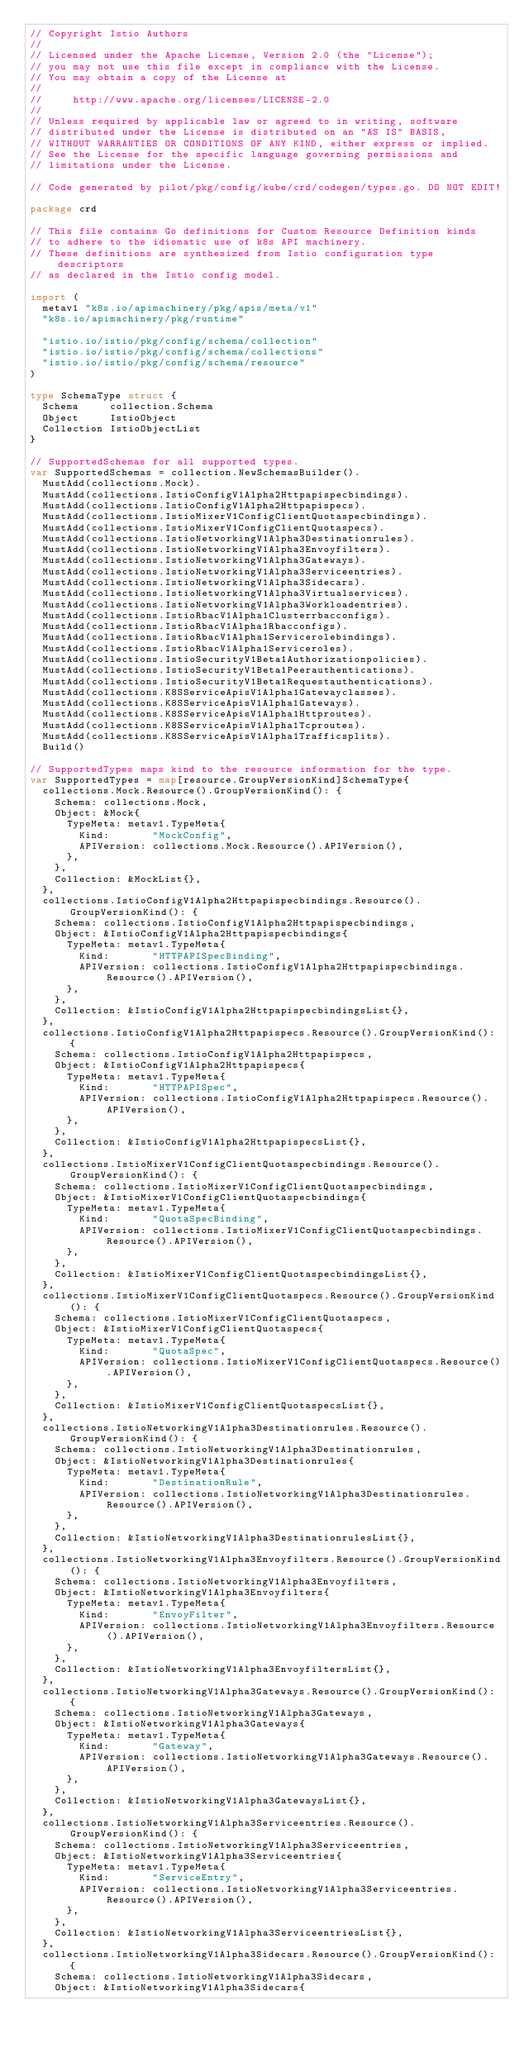Convert code to text. <code><loc_0><loc_0><loc_500><loc_500><_Go_>// Copyright Istio Authors
//
// Licensed under the Apache License, Version 2.0 (the "License");
// you may not use this file except in compliance with the License.
// You may obtain a copy of the License at
//
//     http://www.apache.org/licenses/LICENSE-2.0
//
// Unless required by applicable law or agreed to in writing, software
// distributed under the License is distributed on an "AS IS" BASIS,
// WITHOUT WARRANTIES OR CONDITIONS OF ANY KIND, either express or implied.
// See the License for the specific language governing permissions and
// limitations under the License.

// Code generated by pilot/pkg/config/kube/crd/codegen/types.go. DO NOT EDIT!

package crd

// This file contains Go definitions for Custom Resource Definition kinds
// to adhere to the idiomatic use of k8s API machinery.
// These definitions are synthesized from Istio configuration type descriptors
// as declared in the Istio config model.

import (
	metav1 "k8s.io/apimachinery/pkg/apis/meta/v1"
	"k8s.io/apimachinery/pkg/runtime"

	"istio.io/istio/pkg/config/schema/collection"
	"istio.io/istio/pkg/config/schema/collections"
	"istio.io/istio/pkg/config/schema/resource"
)

type SchemaType struct {
	Schema     collection.Schema
	Object     IstioObject
	Collection IstioObjectList
}

// SupportedSchemas for all supported types.
var SupportedSchemas = collection.NewSchemasBuilder().
	MustAdd(collections.Mock).
	MustAdd(collections.IstioConfigV1Alpha2Httpapispecbindings).
	MustAdd(collections.IstioConfigV1Alpha2Httpapispecs).
	MustAdd(collections.IstioMixerV1ConfigClientQuotaspecbindings).
	MustAdd(collections.IstioMixerV1ConfigClientQuotaspecs).
	MustAdd(collections.IstioNetworkingV1Alpha3Destinationrules).
	MustAdd(collections.IstioNetworkingV1Alpha3Envoyfilters).
	MustAdd(collections.IstioNetworkingV1Alpha3Gateways).
	MustAdd(collections.IstioNetworkingV1Alpha3Serviceentries).
	MustAdd(collections.IstioNetworkingV1Alpha3Sidecars).
	MustAdd(collections.IstioNetworkingV1Alpha3Virtualservices).
	MustAdd(collections.IstioNetworkingV1Alpha3Workloadentries).
	MustAdd(collections.IstioRbacV1Alpha1Clusterrbacconfigs).
	MustAdd(collections.IstioRbacV1Alpha1Rbacconfigs).
	MustAdd(collections.IstioRbacV1Alpha1Servicerolebindings).
	MustAdd(collections.IstioRbacV1Alpha1Serviceroles).
	MustAdd(collections.IstioSecurityV1Beta1Authorizationpolicies).
	MustAdd(collections.IstioSecurityV1Beta1Peerauthentications).
	MustAdd(collections.IstioSecurityV1Beta1Requestauthentications).
	MustAdd(collections.K8SServiceApisV1Alpha1Gatewayclasses).
	MustAdd(collections.K8SServiceApisV1Alpha1Gateways).
	MustAdd(collections.K8SServiceApisV1Alpha1Httproutes).
	MustAdd(collections.K8SServiceApisV1Alpha1Tcproutes).
	MustAdd(collections.K8SServiceApisV1Alpha1Trafficsplits).
	Build()

// SupportedTypes maps kind to the resource information for the type.
var SupportedTypes = map[resource.GroupVersionKind]SchemaType{
	collections.Mock.Resource().GroupVersionKind(): {
		Schema: collections.Mock,
		Object: &Mock{
			TypeMeta: metav1.TypeMeta{
				Kind:       "MockConfig",
				APIVersion: collections.Mock.Resource().APIVersion(),
			},
		},
		Collection: &MockList{},
	},
	collections.IstioConfigV1Alpha2Httpapispecbindings.Resource().GroupVersionKind(): {
		Schema: collections.IstioConfigV1Alpha2Httpapispecbindings,
		Object: &IstioConfigV1Alpha2Httpapispecbindings{
			TypeMeta: metav1.TypeMeta{
				Kind:       "HTTPAPISpecBinding",
				APIVersion: collections.IstioConfigV1Alpha2Httpapispecbindings.Resource().APIVersion(),
			},
		},
		Collection: &IstioConfigV1Alpha2HttpapispecbindingsList{},
	},
	collections.IstioConfigV1Alpha2Httpapispecs.Resource().GroupVersionKind(): {
		Schema: collections.IstioConfigV1Alpha2Httpapispecs,
		Object: &IstioConfigV1Alpha2Httpapispecs{
			TypeMeta: metav1.TypeMeta{
				Kind:       "HTTPAPISpec",
				APIVersion: collections.IstioConfigV1Alpha2Httpapispecs.Resource().APIVersion(),
			},
		},
		Collection: &IstioConfigV1Alpha2HttpapispecsList{},
	},
	collections.IstioMixerV1ConfigClientQuotaspecbindings.Resource().GroupVersionKind(): {
		Schema: collections.IstioMixerV1ConfigClientQuotaspecbindings,
		Object: &IstioMixerV1ConfigClientQuotaspecbindings{
			TypeMeta: metav1.TypeMeta{
				Kind:       "QuotaSpecBinding",
				APIVersion: collections.IstioMixerV1ConfigClientQuotaspecbindings.Resource().APIVersion(),
			},
		},
		Collection: &IstioMixerV1ConfigClientQuotaspecbindingsList{},
	},
	collections.IstioMixerV1ConfigClientQuotaspecs.Resource().GroupVersionKind(): {
		Schema: collections.IstioMixerV1ConfigClientQuotaspecs,
		Object: &IstioMixerV1ConfigClientQuotaspecs{
			TypeMeta: metav1.TypeMeta{
				Kind:       "QuotaSpec",
				APIVersion: collections.IstioMixerV1ConfigClientQuotaspecs.Resource().APIVersion(),
			},
		},
		Collection: &IstioMixerV1ConfigClientQuotaspecsList{},
	},
	collections.IstioNetworkingV1Alpha3Destinationrules.Resource().GroupVersionKind(): {
		Schema: collections.IstioNetworkingV1Alpha3Destinationrules,
		Object: &IstioNetworkingV1Alpha3Destinationrules{
			TypeMeta: metav1.TypeMeta{
				Kind:       "DestinationRule",
				APIVersion: collections.IstioNetworkingV1Alpha3Destinationrules.Resource().APIVersion(),
			},
		},
		Collection: &IstioNetworkingV1Alpha3DestinationrulesList{},
	},
	collections.IstioNetworkingV1Alpha3Envoyfilters.Resource().GroupVersionKind(): {
		Schema: collections.IstioNetworkingV1Alpha3Envoyfilters,
		Object: &IstioNetworkingV1Alpha3Envoyfilters{
			TypeMeta: metav1.TypeMeta{
				Kind:       "EnvoyFilter",
				APIVersion: collections.IstioNetworkingV1Alpha3Envoyfilters.Resource().APIVersion(),
			},
		},
		Collection: &IstioNetworkingV1Alpha3EnvoyfiltersList{},
	},
	collections.IstioNetworkingV1Alpha3Gateways.Resource().GroupVersionKind(): {
		Schema: collections.IstioNetworkingV1Alpha3Gateways,
		Object: &IstioNetworkingV1Alpha3Gateways{
			TypeMeta: metav1.TypeMeta{
				Kind:       "Gateway",
				APIVersion: collections.IstioNetworkingV1Alpha3Gateways.Resource().APIVersion(),
			},
		},
		Collection: &IstioNetworkingV1Alpha3GatewaysList{},
	},
	collections.IstioNetworkingV1Alpha3Serviceentries.Resource().GroupVersionKind(): {
		Schema: collections.IstioNetworkingV1Alpha3Serviceentries,
		Object: &IstioNetworkingV1Alpha3Serviceentries{
			TypeMeta: metav1.TypeMeta{
				Kind:       "ServiceEntry",
				APIVersion: collections.IstioNetworkingV1Alpha3Serviceentries.Resource().APIVersion(),
			},
		},
		Collection: &IstioNetworkingV1Alpha3ServiceentriesList{},
	},
	collections.IstioNetworkingV1Alpha3Sidecars.Resource().GroupVersionKind(): {
		Schema: collections.IstioNetworkingV1Alpha3Sidecars,
		Object: &IstioNetworkingV1Alpha3Sidecars{</code> 